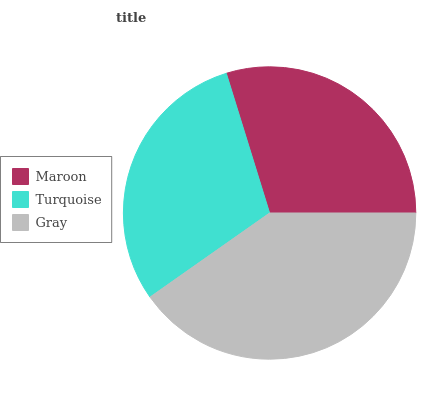Is Maroon the minimum?
Answer yes or no. Yes. Is Gray the maximum?
Answer yes or no. Yes. Is Turquoise the minimum?
Answer yes or no. No. Is Turquoise the maximum?
Answer yes or no. No. Is Turquoise greater than Maroon?
Answer yes or no. Yes. Is Maroon less than Turquoise?
Answer yes or no. Yes. Is Maroon greater than Turquoise?
Answer yes or no. No. Is Turquoise less than Maroon?
Answer yes or no. No. Is Turquoise the high median?
Answer yes or no. Yes. Is Turquoise the low median?
Answer yes or no. Yes. Is Maroon the high median?
Answer yes or no. No. Is Gray the low median?
Answer yes or no. No. 